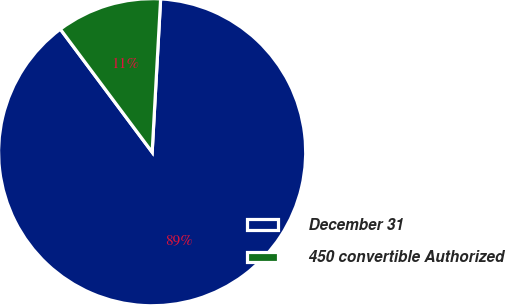Convert chart. <chart><loc_0><loc_0><loc_500><loc_500><pie_chart><fcel>December 31<fcel>450 convertible Authorized<nl><fcel>88.92%<fcel>11.08%<nl></chart> 